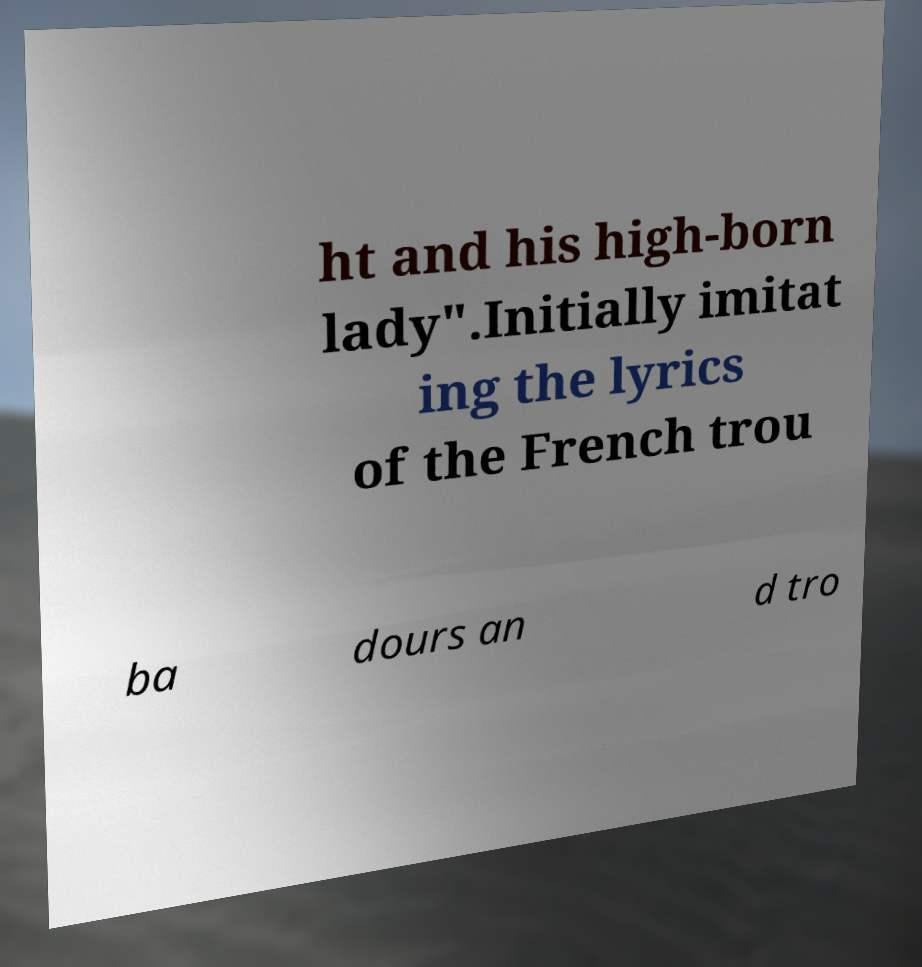Can you accurately transcribe the text from the provided image for me? ht and his high-born lady".Initially imitat ing the lyrics of the French trou ba dours an d tro 